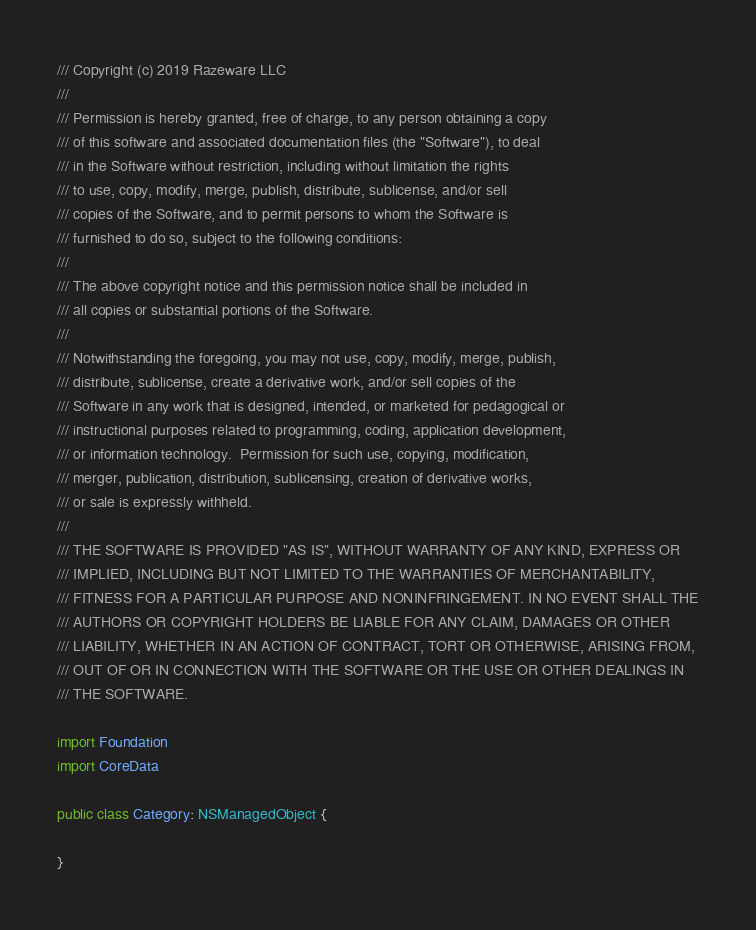<code> <loc_0><loc_0><loc_500><loc_500><_Swift_>/// Copyright (c) 2019 Razeware LLC
///
/// Permission is hereby granted, free of charge, to any person obtaining a copy
/// of this software and associated documentation files (the "Software"), to deal
/// in the Software without restriction, including without limitation the rights
/// to use, copy, modify, merge, publish, distribute, sublicense, and/or sell
/// copies of the Software, and to permit persons to whom the Software is
/// furnished to do so, subject to the following conditions:
///
/// The above copyright notice and this permission notice shall be included in
/// all copies or substantial portions of the Software.
///
/// Notwithstanding the foregoing, you may not use, copy, modify, merge, publish,
/// distribute, sublicense, create a derivative work, and/or sell copies of the
/// Software in any work that is designed, intended, or marketed for pedagogical or
/// instructional purposes related to programming, coding, application development,
/// or information technology.  Permission for such use, copying, modification,
/// merger, publication, distribution, sublicensing, creation of derivative works,
/// or sale is expressly withheld.
///
/// THE SOFTWARE IS PROVIDED "AS IS", WITHOUT WARRANTY OF ANY KIND, EXPRESS OR
/// IMPLIED, INCLUDING BUT NOT LIMITED TO THE WARRANTIES OF MERCHANTABILITY,
/// FITNESS FOR A PARTICULAR PURPOSE AND NONINFRINGEMENT. IN NO EVENT SHALL THE
/// AUTHORS OR COPYRIGHT HOLDERS BE LIABLE FOR ANY CLAIM, DAMAGES OR OTHER
/// LIABILITY, WHETHER IN AN ACTION OF CONTRACT, TORT OR OTHERWISE, ARISING FROM,
/// OUT OF OR IN CONNECTION WITH THE SOFTWARE OR THE USE OR OTHER DEALINGS IN
/// THE SOFTWARE.

import Foundation
import CoreData

public class Category: NSManagedObject {
  
}
</code> 